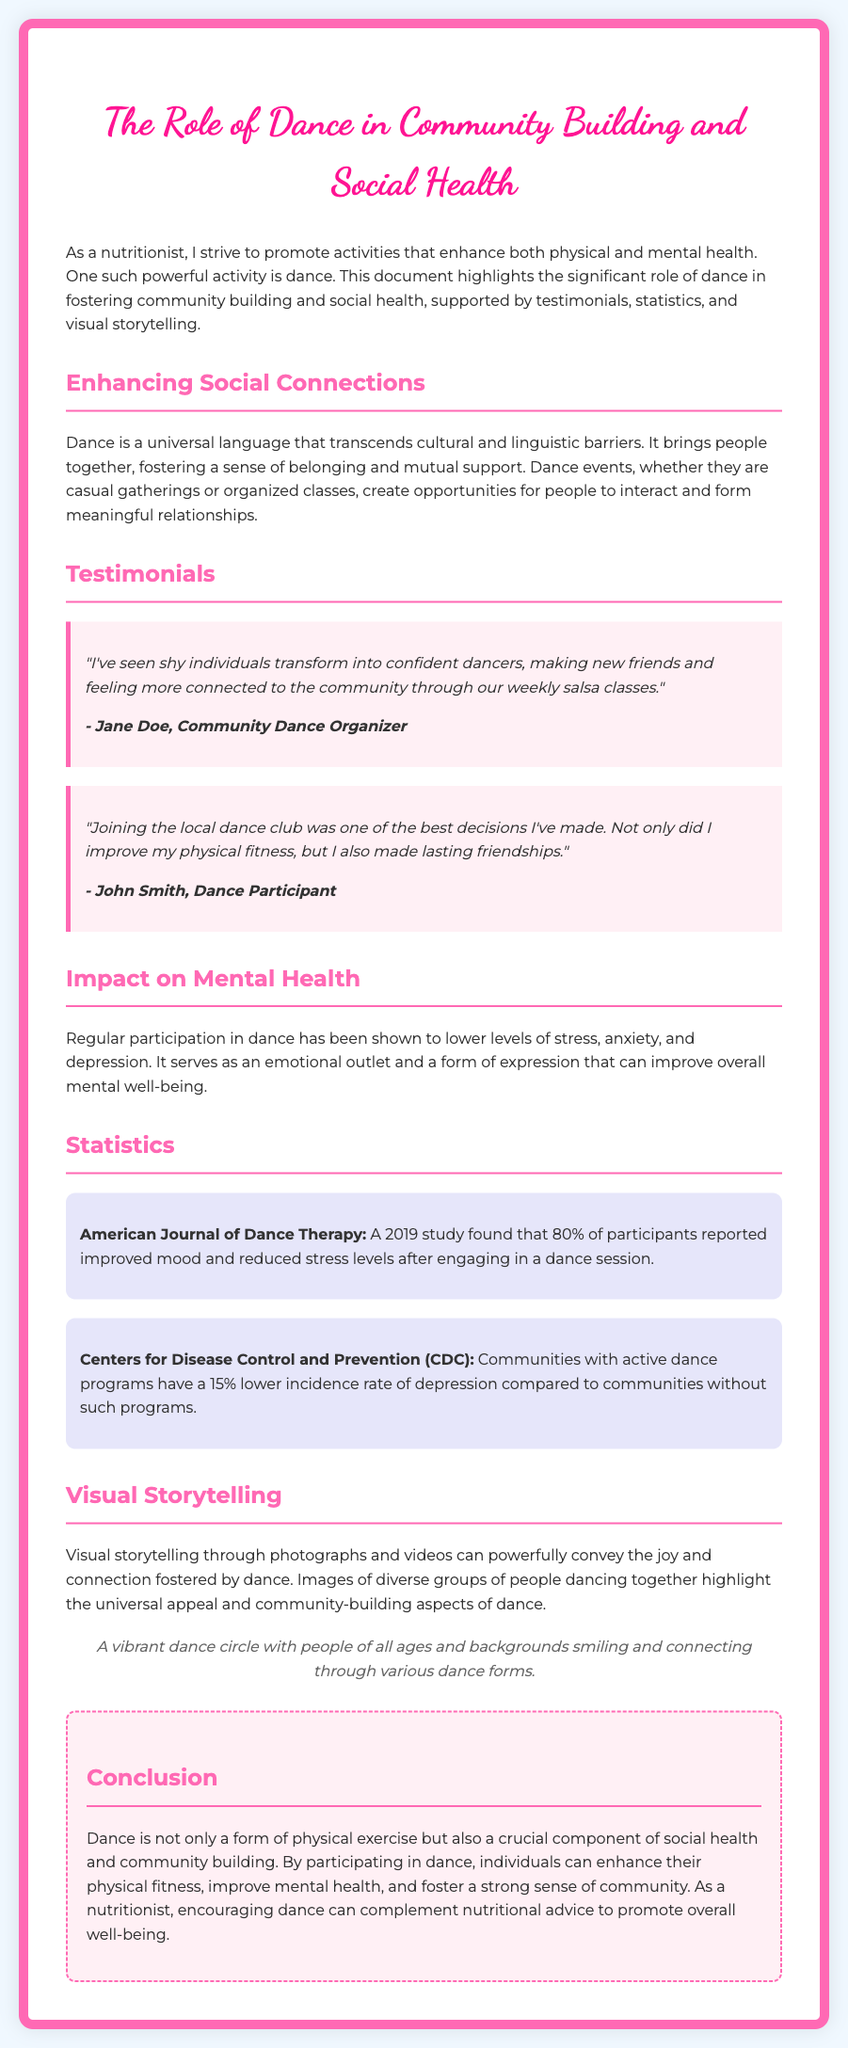what is the title of the document? The title of the document is stated at the beginning and clearly indicates the topic of the document.
Answer: The Role of Dance in Community Building and Social Health who is the author of the testimonials? The testimonials feature firsthand accounts from individuals involved in dance and community activities, with names provided.
Answer: Jane Doe and John Smith what percentage of participants reported improved mood after a dance session? This statistic is found in the American Journal of Dance Therapy section and quantifies the positive mood change after dance.
Answer: 80% what is the percentage lower incidence rate of depression in communities with active dance programs? This statistic is specified by the Centers for Disease Control and Prevention, highlighting the mental health benefits of dance.
Answer: 15% how does dance contribute to mental health? The document describes dance's role in alleviating emotional burdens and fostering expression, which directly relates to mental health improvement.
Answer: Lowers stress, anxiety, and depression what style is used for the main title? The style of the main title is characterized by a specific font choice that enhances the document's artistic appeal.
Answer: Dancing Script what are the main benefits of participating in dance mentioned? The document cites both physical and mental health benefits alongside social aspects, highlighting dance's wide-ranging impact.
Answer: Physical fitness, improved mental health, community connection which research journal is referenced for statistics? The document mentions a specific journal where a relevant study on dance and mood improvement was published, which validates the documented statistics.
Answer: American Journal of Dance Therapy 